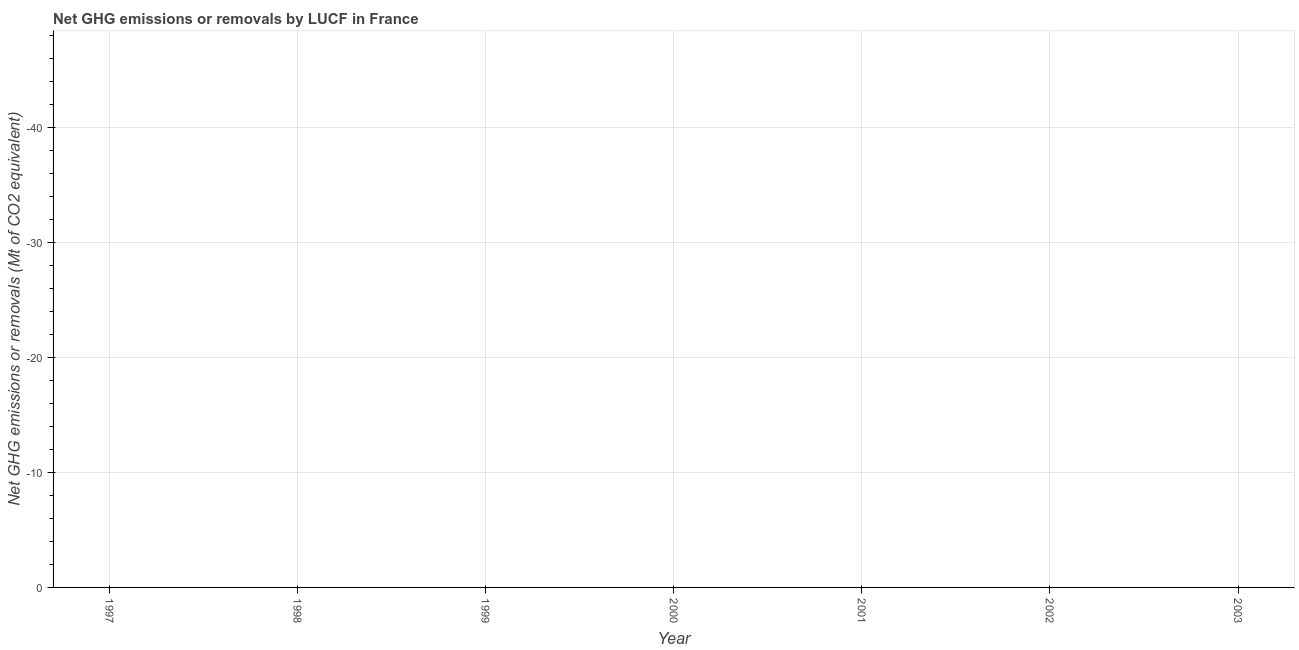Across all years, what is the minimum ghg net emissions or removals?
Make the answer very short. 0. What is the average ghg net emissions or removals per year?
Keep it short and to the point. 0. In how many years, is the ghg net emissions or removals greater than -32 Mt?
Keep it short and to the point. 0. Does the ghg net emissions or removals monotonically increase over the years?
Ensure brevity in your answer.  No. What is the difference between two consecutive major ticks on the Y-axis?
Provide a succinct answer. 10. Does the graph contain grids?
Make the answer very short. Yes. What is the title of the graph?
Your answer should be compact. Net GHG emissions or removals by LUCF in France. What is the label or title of the Y-axis?
Your answer should be very brief. Net GHG emissions or removals (Mt of CO2 equivalent). What is the Net GHG emissions or removals (Mt of CO2 equivalent) of 1997?
Ensure brevity in your answer.  0. What is the Net GHG emissions or removals (Mt of CO2 equivalent) in 1998?
Provide a succinct answer. 0. What is the Net GHG emissions or removals (Mt of CO2 equivalent) of 2000?
Your answer should be compact. 0. What is the Net GHG emissions or removals (Mt of CO2 equivalent) in 2003?
Provide a short and direct response. 0. 